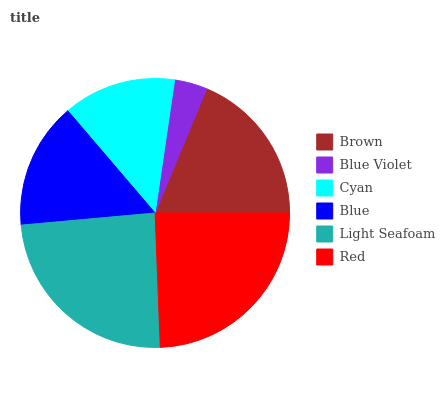Is Blue Violet the minimum?
Answer yes or no. Yes. Is Red the maximum?
Answer yes or no. Yes. Is Cyan the minimum?
Answer yes or no. No. Is Cyan the maximum?
Answer yes or no. No. Is Cyan greater than Blue Violet?
Answer yes or no. Yes. Is Blue Violet less than Cyan?
Answer yes or no. Yes. Is Blue Violet greater than Cyan?
Answer yes or no. No. Is Cyan less than Blue Violet?
Answer yes or no. No. Is Brown the high median?
Answer yes or no. Yes. Is Blue the low median?
Answer yes or no. Yes. Is Blue the high median?
Answer yes or no. No. Is Cyan the low median?
Answer yes or no. No. 